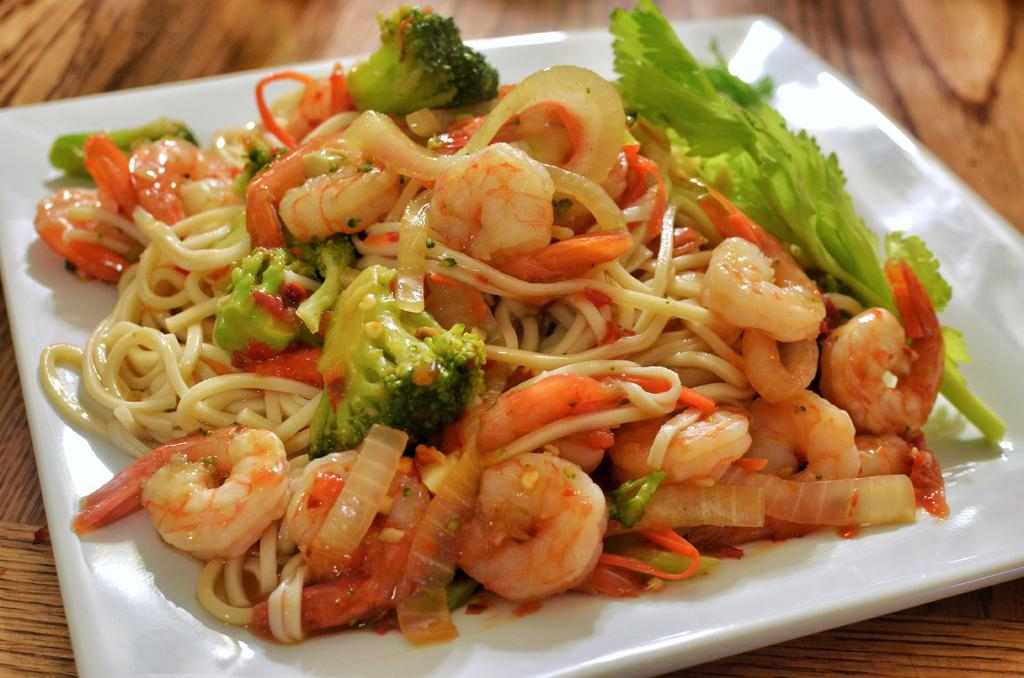What is on the white plate in the image? There is food on a white plate in the image. Can you describe the wooden object at the bottom of the image? There is a wooden object at the bottom of the image. What type of guitar can be seen playing arithmetic in the image? There is no guitar or arithmetic present in the image; it only features food on a white plate and a wooden object. How many people are laughing in the image? There are no people or laughter depicted in the image. 